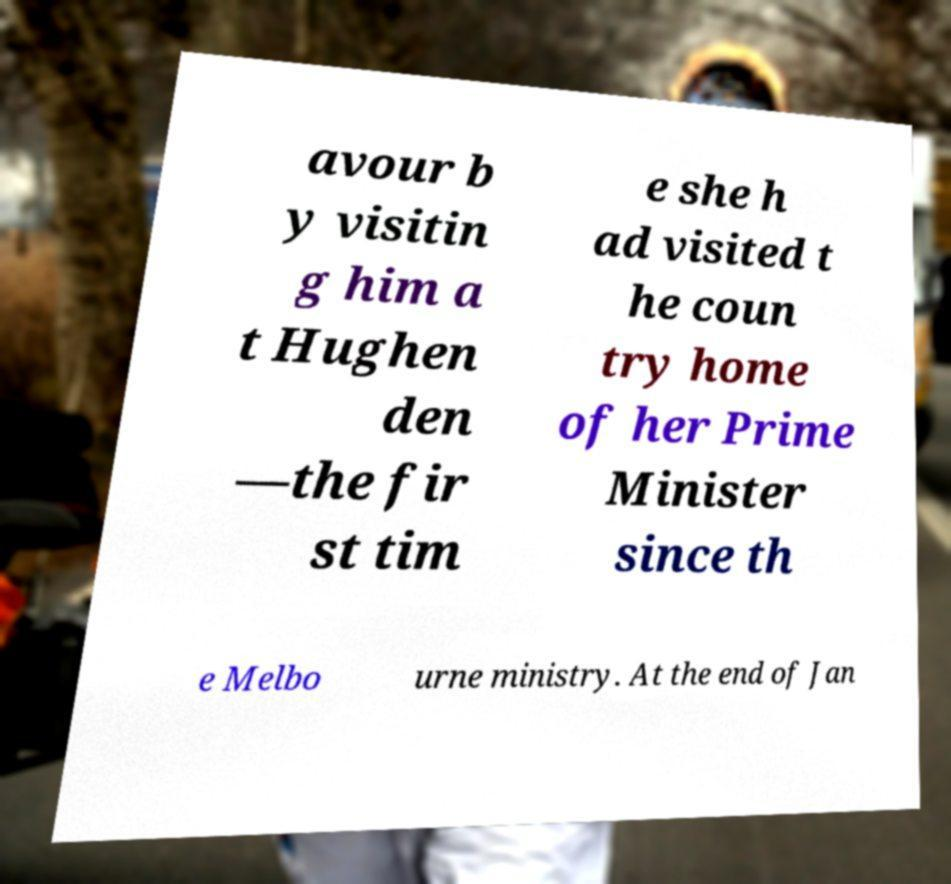What messages or text are displayed in this image? I need them in a readable, typed format. avour b y visitin g him a t Hughen den —the fir st tim e she h ad visited t he coun try home of her Prime Minister since th e Melbo urne ministry. At the end of Jan 